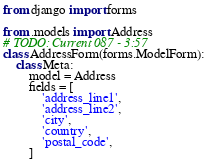<code> <loc_0><loc_0><loc_500><loc_500><_Python_>from django import forms

from .models import Address
# TODO: Current 087 - 3:57
class AddressForm(forms.ModelForm):
    class Meta:
        model = Address
        fields = [
            'address_line1',
            'address_line2',
            'city',
            'country',
            'postal_code',
        ]
</code> 